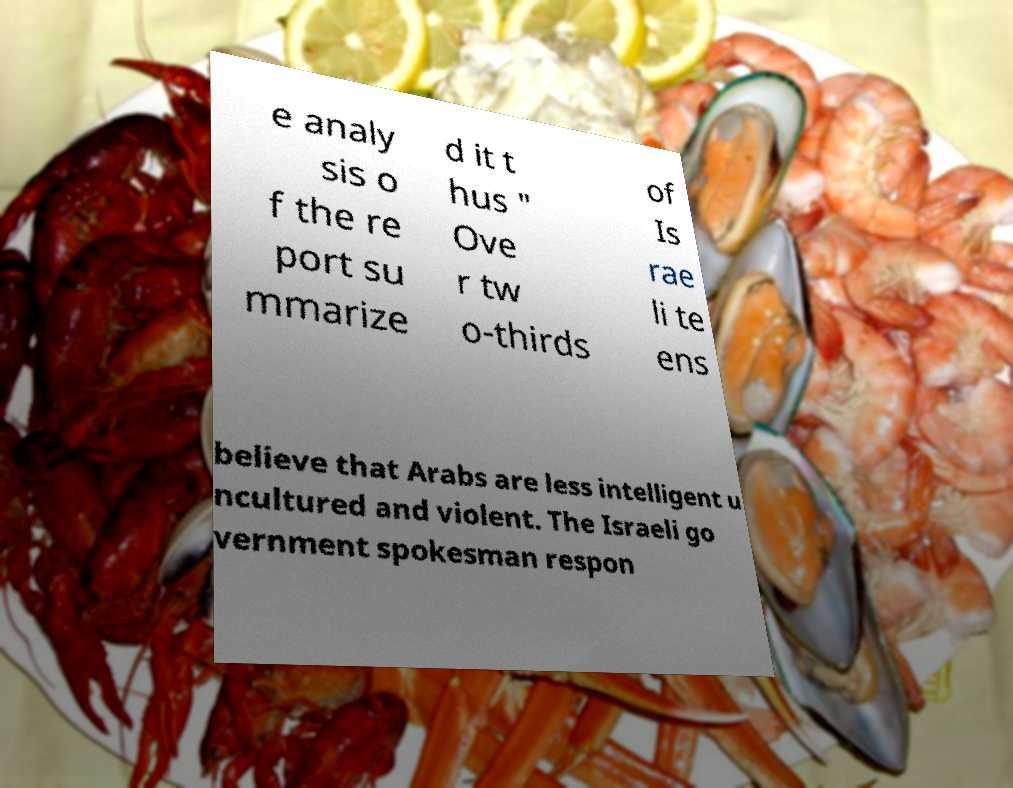There's text embedded in this image that I need extracted. Can you transcribe it verbatim? e analy sis o f the re port su mmarize d it t hus " Ove r tw o-thirds of Is rae li te ens believe that Arabs are less intelligent u ncultured and violent. The Israeli go vernment spokesman respon 